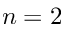<formula> <loc_0><loc_0><loc_500><loc_500>n = 2</formula> 